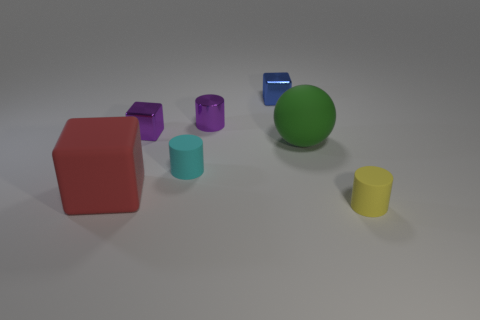What number of other objects are there of the same size as the cyan rubber object?
Make the answer very short. 4. The tiny object behind the tiny cylinder behind the big thing that is behind the big red cube is what color?
Offer a very short reply. Blue. What number of other things are the same shape as the green thing?
Keep it short and to the point. 0. Are there any small matte objects on the left side of the purple metallic object right of the small cyan cylinder?
Offer a terse response. Yes. How many matte things are small cyan objects or small objects?
Your answer should be very brief. 2. There is a small thing that is both to the left of the sphere and in front of the big matte ball; what material is it made of?
Your answer should be compact. Rubber. There is a small thing to the left of the rubber cylinder left of the rubber sphere; is there a tiny purple metal object behind it?
Give a very brief answer. Yes. What shape is the yellow thing that is the same material as the green ball?
Offer a terse response. Cylinder. Are there fewer tiny yellow cylinders that are on the left side of the red rubber thing than cylinders that are behind the large rubber sphere?
Offer a very short reply. Yes. How many tiny objects are red rubber cylinders or yellow cylinders?
Give a very brief answer. 1. 